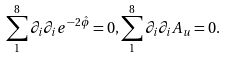<formula> <loc_0><loc_0><loc_500><loc_500>\sum _ { 1 } ^ { 8 } \partial _ { i } \partial _ { i } e ^ { - 2 \hat { \phi } } = 0 , \sum _ { 1 } ^ { 8 } \partial _ { i } \partial _ { i } A _ { u } = 0 .</formula> 